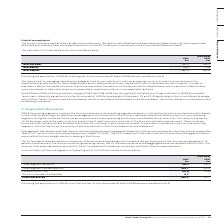According to Auto Trader's financial document, What is the Operational Leadership Team made up of? made up of the Executive Directors and Key Management and is responsible for the strategic decision-making of the Group. The document states: "ief operating decision-maker (‘CODM’). The OLT is made up of the Executive Directors and Key Management and is responsible for the strategic decision-..." Also, What led to the restating of the 2018 values for profit before tax in the table? the application of IFRS 16. The document states: "Following the application of IFRS 16, total capital for the year ended 31 March 2018 has been restated (note 2)...." Also, What are the components in the table which are considered when reconciliating total segment revenue to profit before tax? The document contains multiple relevant values: Total segment Operating profit, Finance costs – net, Profit on the sale of subsidiary. From the document: "Profit on the sale of subsidiary 8.7 – Finance costs – net (10.2) (10.6) Total segment Operating profit 243.7 221.3..." Additionally, In which year was Total segment Operating profit larger? According to the financial document, 2019. The relevant text states: "Group plc Annual Report and Financial Statements 2019 | 101..." Also, can you calculate: What was the change in Total segment Operating profit in 2019 from 2018? Based on the calculation: 243.7-221.3, the result is 22.4 (in millions). This is based on the information: "Total segment Operating profit 243.7 221.3 Total segment Operating profit 243.7 221.3..." The key data points involved are: 221.3, 243.7. Also, can you calculate: What was the percentage change in Total segment Operating profit in 2019 from 2018? To answer this question, I need to perform calculations using the financial data. The calculation is: (243.7-221.3)/221.3, which equals 10.12 (percentage). This is based on the information: "Total segment Operating profit 243.7 221.3 Total segment Operating profit 243.7 221.3..." The key data points involved are: 221.3, 243.7. 